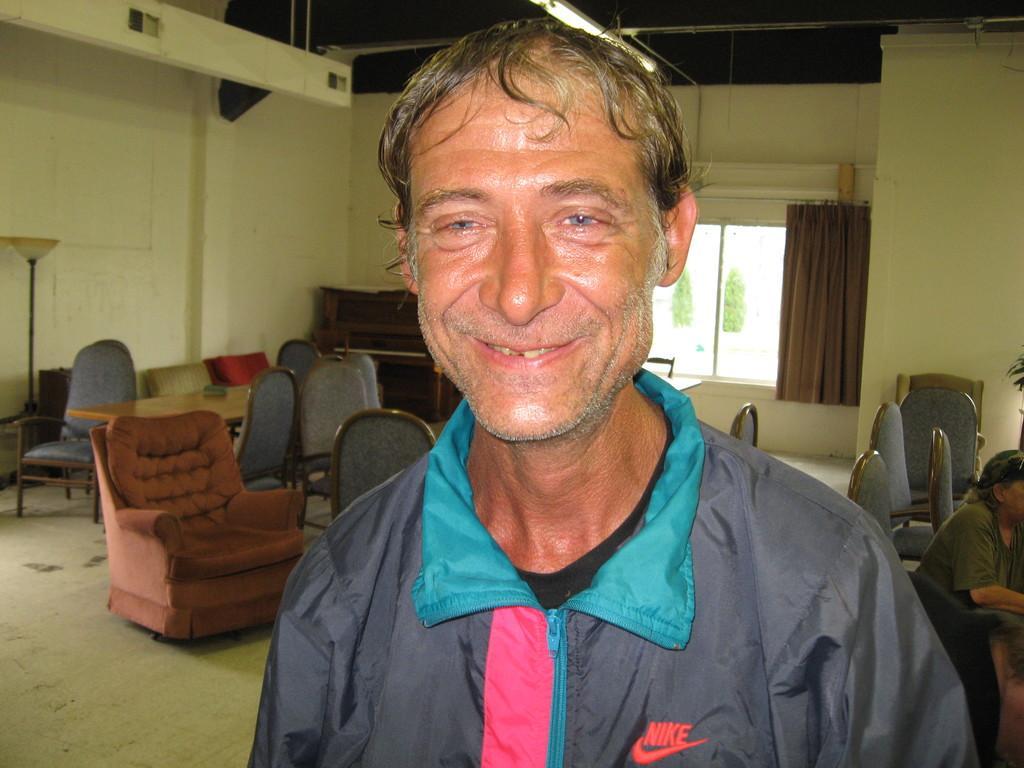Describe this image in one or two sentences. This image has a person smiling. Back to him there are few chairs. At right there is a person. Background there is a curtain, few trees. To the left there is a lamp stand. 